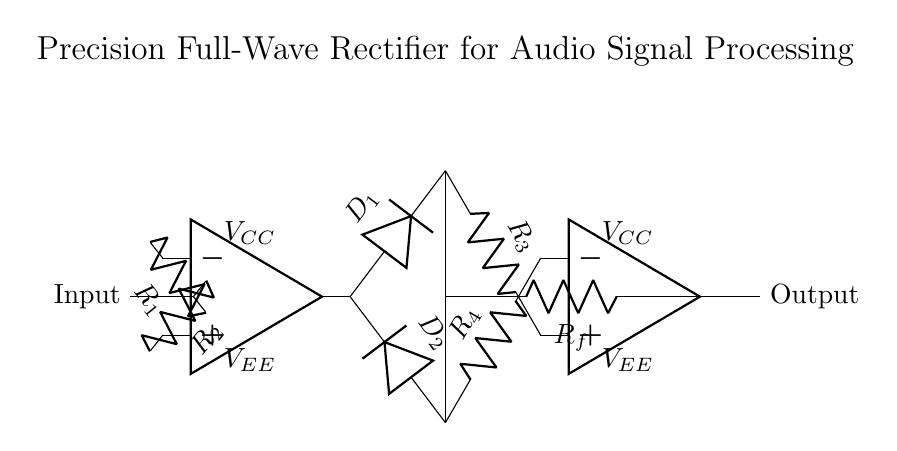What is the role of the op-amps in this circuit? The op-amps are used to amplify the input signal and facilitate the rectifying process, ensuring that both the positive and negative halves of the input waveform are converted into a positive output.
Answer: Amplification and rectification What does the symbol D represent in the circuit? The symbol D represents diodes, which allow current to flow in one direction only, hence enabling the rectification of alternating current signals to direct current.
Answer: Diodes How many resistors are in the circuit? There are four resistors in the circuit labeled as R1, R2, R3, and R4, contributing to the gain and feedback of the op-amps.
Answer: Four What type of rectification does this circuit perform? This circuit performs full-wave rectification by processing both halves of the input signal, converting the entire waveform into a positive voltage.
Answer: Full-wave What is the function of resistor Rf? Resistor Rf is used for feedback in the op-amp circuit, which helps control the gain and ensures stability of the output waveform.
Answer: Feedback control Which component determines the direction of current flow? The diodes D1 and D2 determine the direction of current flow; they only allow current to pass during specific intervals of the input waveform, thus defining the rectification process.
Answer: Diodes What is the output of this rectifier circuit? The output of this rectifier circuit is an audio signal that has been modified to consist of only positive voltages, suitable for further processing or amplification.
Answer: Positive audio signal 